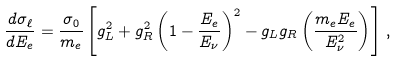Convert formula to latex. <formula><loc_0><loc_0><loc_500><loc_500>\frac { d \sigma _ { \ell } } { d E _ { e } } = \frac { \sigma _ { 0 } } { m _ { e } } \left [ g _ { L } ^ { 2 } + g _ { R } ^ { 2 } \left ( 1 - \frac { E _ { e } } { E _ { \nu } } \right ) ^ { 2 } - g _ { L } g _ { R } \left ( \frac { m _ { e } E _ { e } } { E _ { \nu } ^ { 2 } } \right ) \right ] \, ,</formula> 